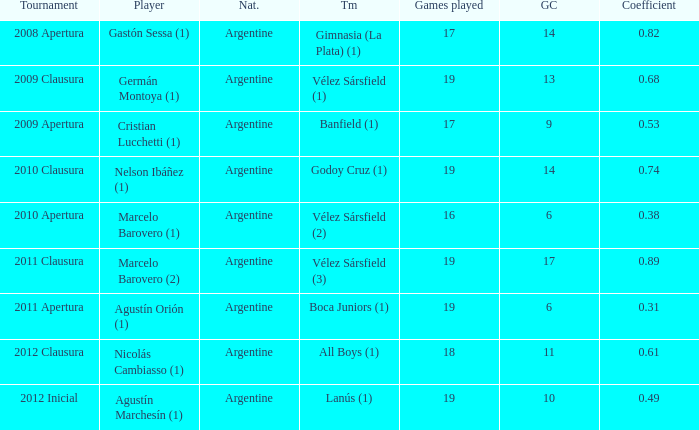Which team was in the 2012 clausura tournament? All Boys (1). 